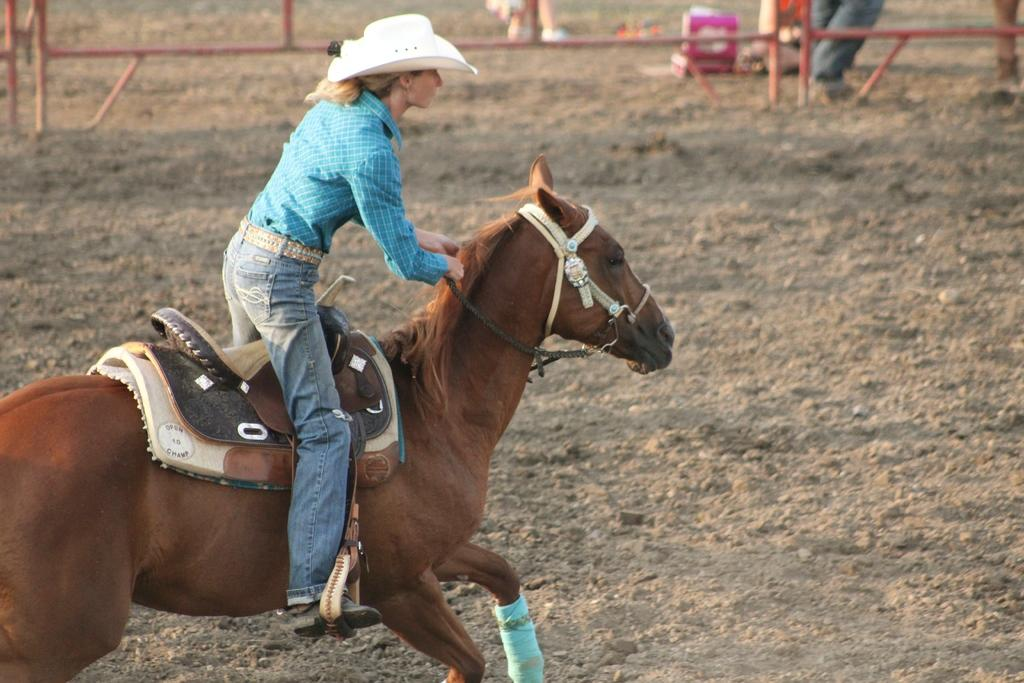Who is the main subject in the picture? The main subject in the picture is a girl. What is the girl doing in the picture? The girl is riding a horse in the picture. What type of terrain is the horse on? The horse is on land in the picture. What color is the girl's shirt? The girl is wearing a blue shirt in the picture. What type of hat is the girl wearing? The girl is wearing a white hat in the picture. What type of pants is the girl wearing? The girl is wearing jeans in the picture. What type of pie is the girl eating while riding the horse? There is no pie present in the image; the girl is riding a horse and not eating anything. 